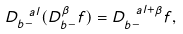<formula> <loc_0><loc_0><loc_500><loc_500>D ^ { \ a l } _ { b - } ( D ^ { \beta } _ { b - } f ) = D ^ { \ a l + \beta } _ { b - } f ,</formula> 